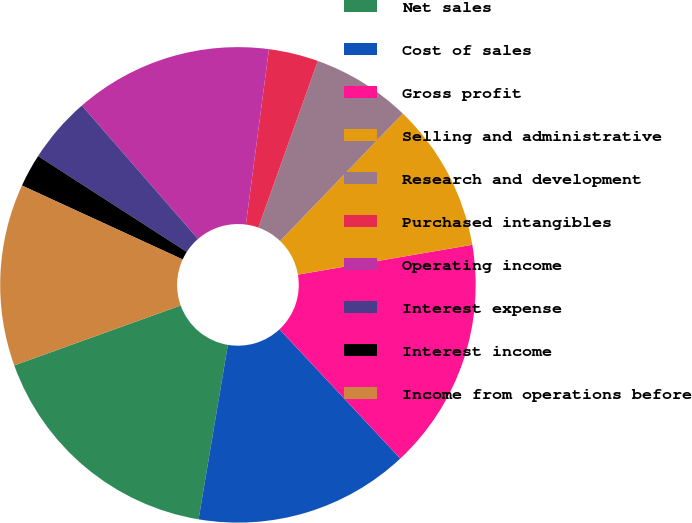<chart> <loc_0><loc_0><loc_500><loc_500><pie_chart><fcel>Net sales<fcel>Cost of sales<fcel>Gross profit<fcel>Selling and administrative<fcel>Research and development<fcel>Purchased intangibles<fcel>Operating income<fcel>Interest expense<fcel>Interest income<fcel>Income from operations before<nl><fcel>16.85%<fcel>14.61%<fcel>15.73%<fcel>10.11%<fcel>6.74%<fcel>3.37%<fcel>13.48%<fcel>4.49%<fcel>2.25%<fcel>12.36%<nl></chart> 